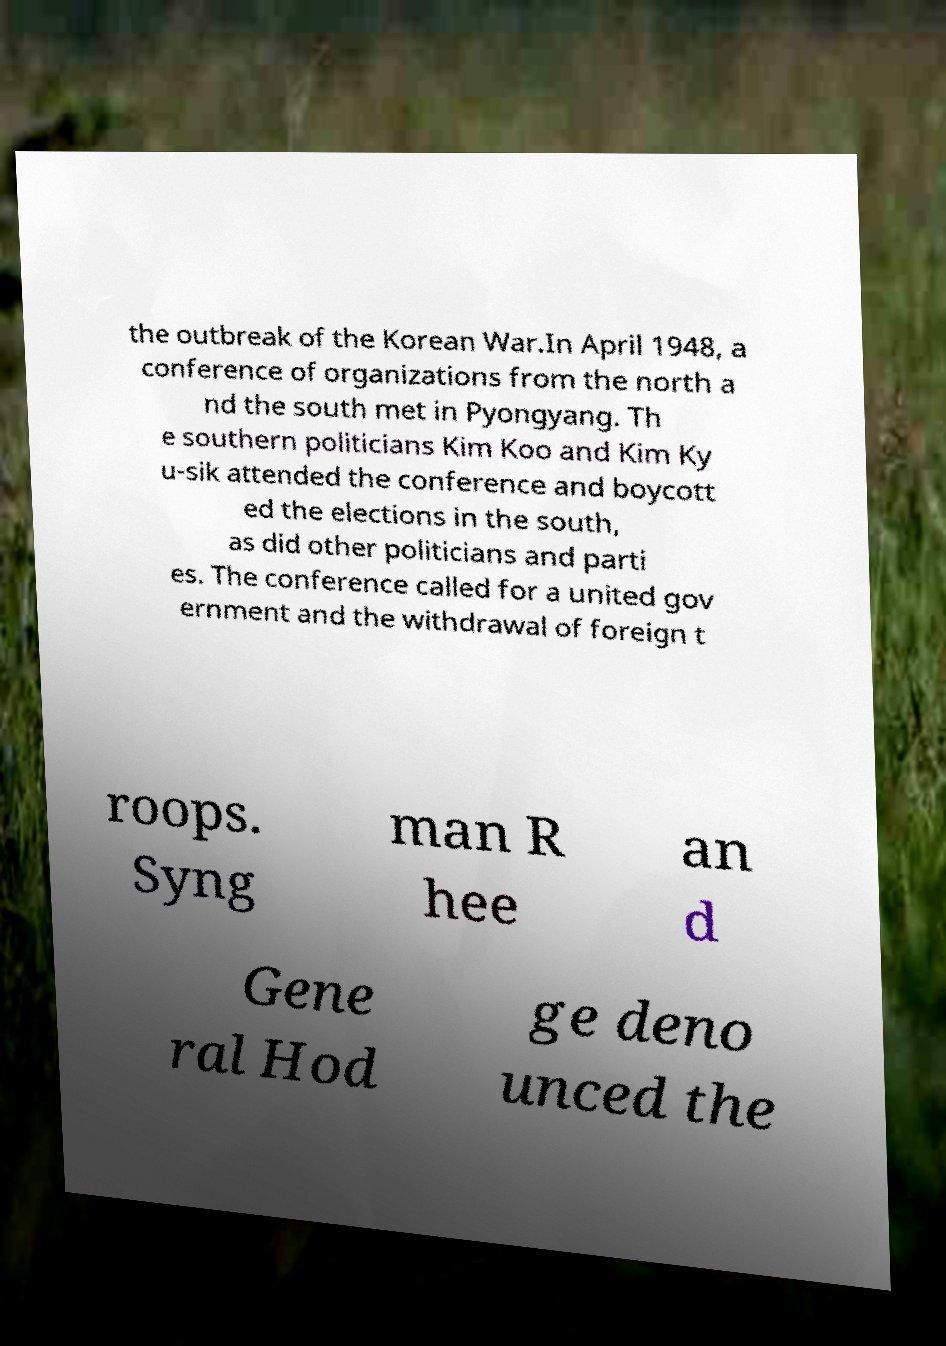Please read and relay the text visible in this image. What does it say? the outbreak of the Korean War.In April 1948, a conference of organizations from the north a nd the south met in Pyongyang. Th e southern politicians Kim Koo and Kim Ky u-sik attended the conference and boycott ed the elections in the south, as did other politicians and parti es. The conference called for a united gov ernment and the withdrawal of foreign t roops. Syng man R hee an d Gene ral Hod ge deno unced the 